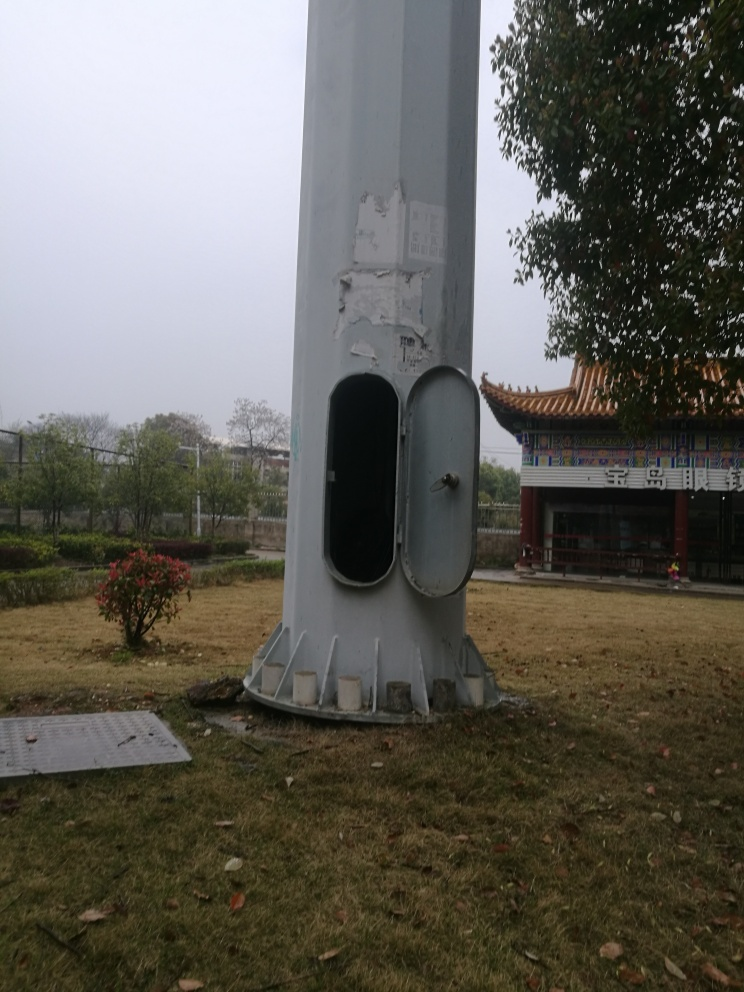What time of year does this image suggest and how can you tell? The image suggests it may be late autumn or early winter. This is indicated by the bare trees, the presence of fallen leaves on the grass, and the general somber lighting, which might hint at the colder months of the year. 